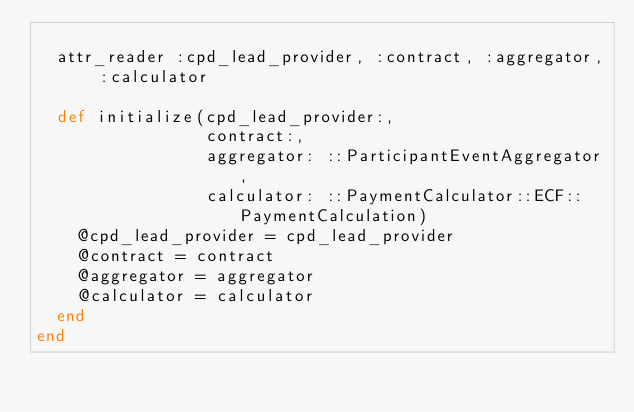Convert code to text. <code><loc_0><loc_0><loc_500><loc_500><_Ruby_>
  attr_reader :cpd_lead_provider, :contract, :aggregator, :calculator

  def initialize(cpd_lead_provider:,
                 contract:,
                 aggregator: ::ParticipantEventAggregator,
                 calculator: ::PaymentCalculator::ECF::PaymentCalculation)
    @cpd_lead_provider = cpd_lead_provider
    @contract = contract
    @aggregator = aggregator
    @calculator = calculator
  end
end
</code> 